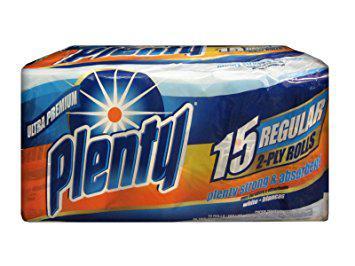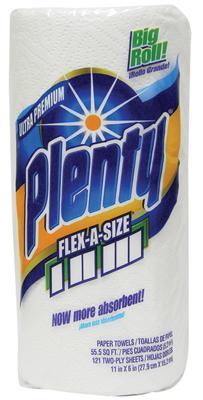The first image is the image on the left, the second image is the image on the right. For the images shown, is this caption "The lefthand image contains one wrapped multi-roll of towels, and the right image shows one upright roll." true? Answer yes or no. Yes. 